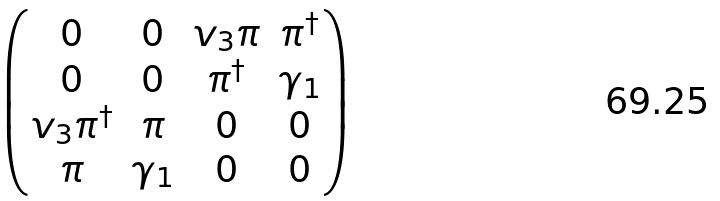<formula> <loc_0><loc_0><loc_500><loc_500>\begin{pmatrix} 0 & 0 & v _ { 3 } \pi & \pi ^ { \dagger } \\ 0 & 0 & \pi ^ { \dagger } & \gamma _ { 1 } \\ v _ { 3 } \pi ^ { \dagger } & \pi & 0 & 0 \\ \pi & \gamma _ { 1 } & 0 & 0 \\ \end{pmatrix}</formula> 